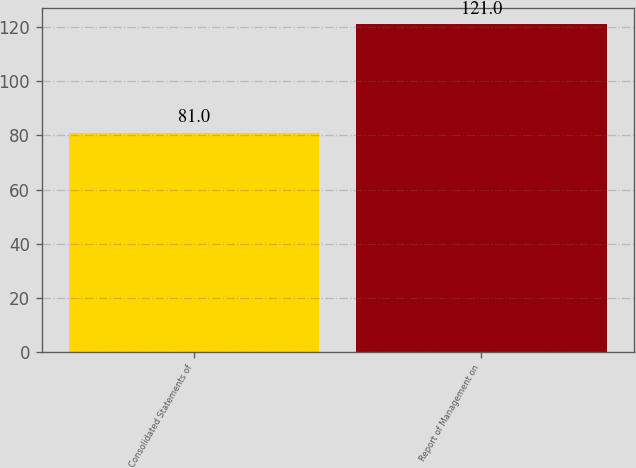Convert chart. <chart><loc_0><loc_0><loc_500><loc_500><bar_chart><fcel>Consolidated Statements of<fcel>Report of Management on<nl><fcel>81<fcel>121<nl></chart> 